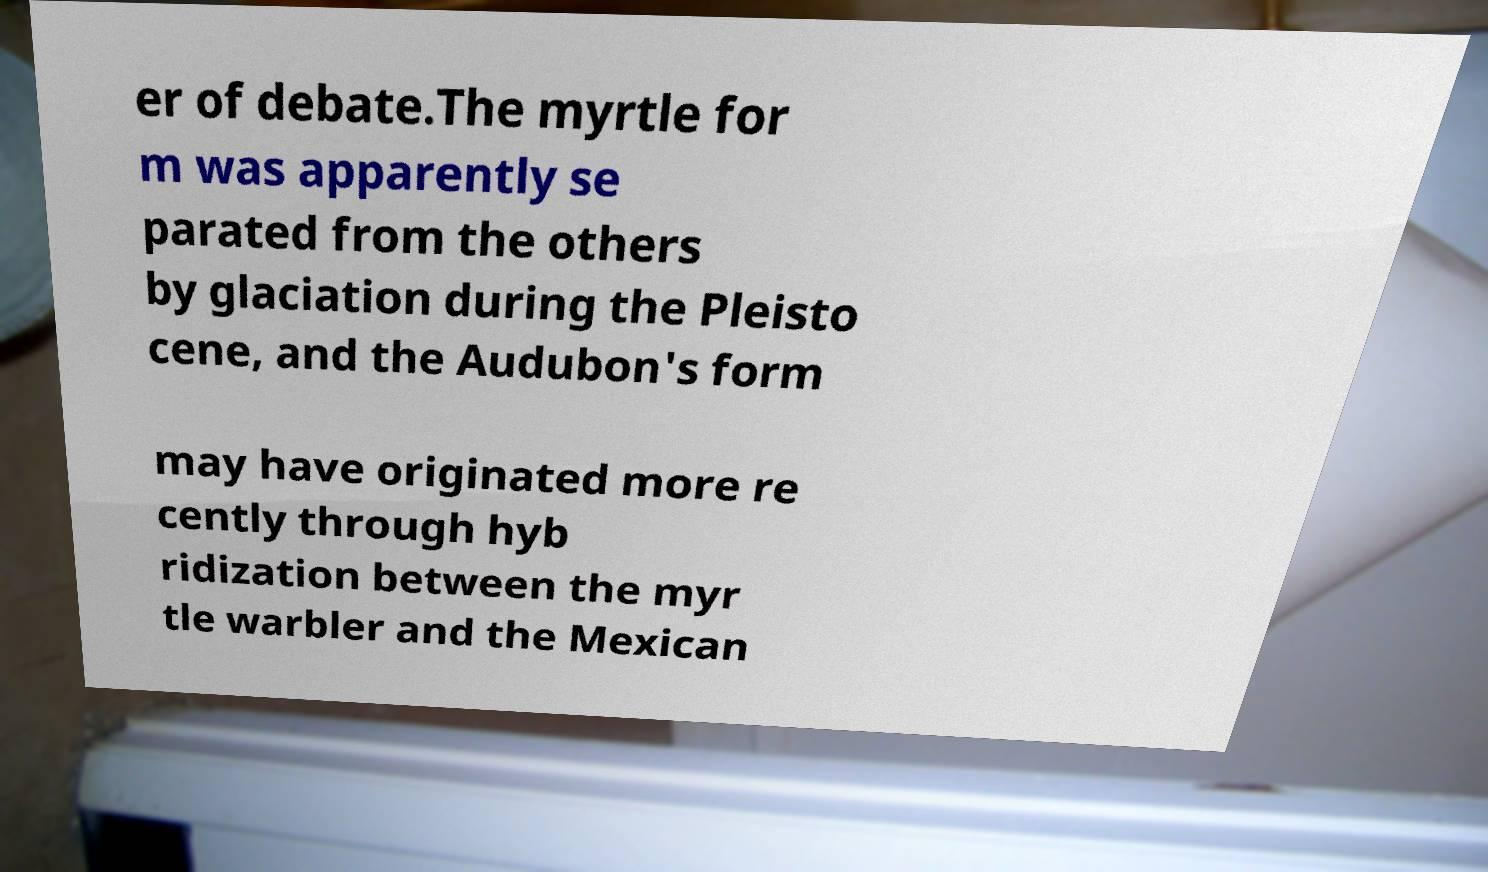Could you assist in decoding the text presented in this image and type it out clearly? er of debate.The myrtle for m was apparently se parated from the others by glaciation during the Pleisto cene, and the Audubon's form may have originated more re cently through hyb ridization between the myr tle warbler and the Mexican 